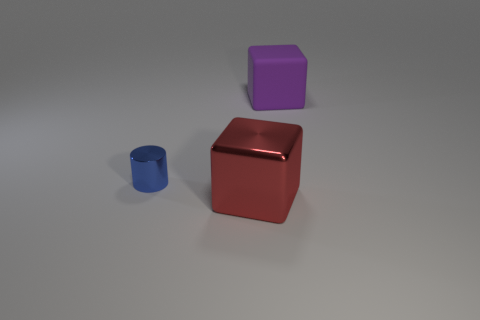There is a cube that is in front of the large matte block; what is it made of?
Give a very brief answer. Metal. What is the material of the big red cube?
Your answer should be compact. Metal. Do the big block that is in front of the tiny blue metal cylinder and the purple object have the same material?
Provide a succinct answer. No. Is the number of big things that are behind the purple rubber cube less than the number of small yellow shiny cylinders?
Offer a very short reply. No. What color is the other block that is the same size as the rubber cube?
Your answer should be compact. Red. What number of other big things are the same shape as the purple thing?
Provide a short and direct response. 1. What color is the large thing in front of the tiny metallic cylinder?
Provide a succinct answer. Red. How many shiny things are tiny blue things or big cyan spheres?
Your answer should be compact. 1. What number of red blocks have the same size as the rubber object?
Your response must be concise. 1. What color is the object that is in front of the purple cube and behind the metal block?
Offer a terse response. Blue. 